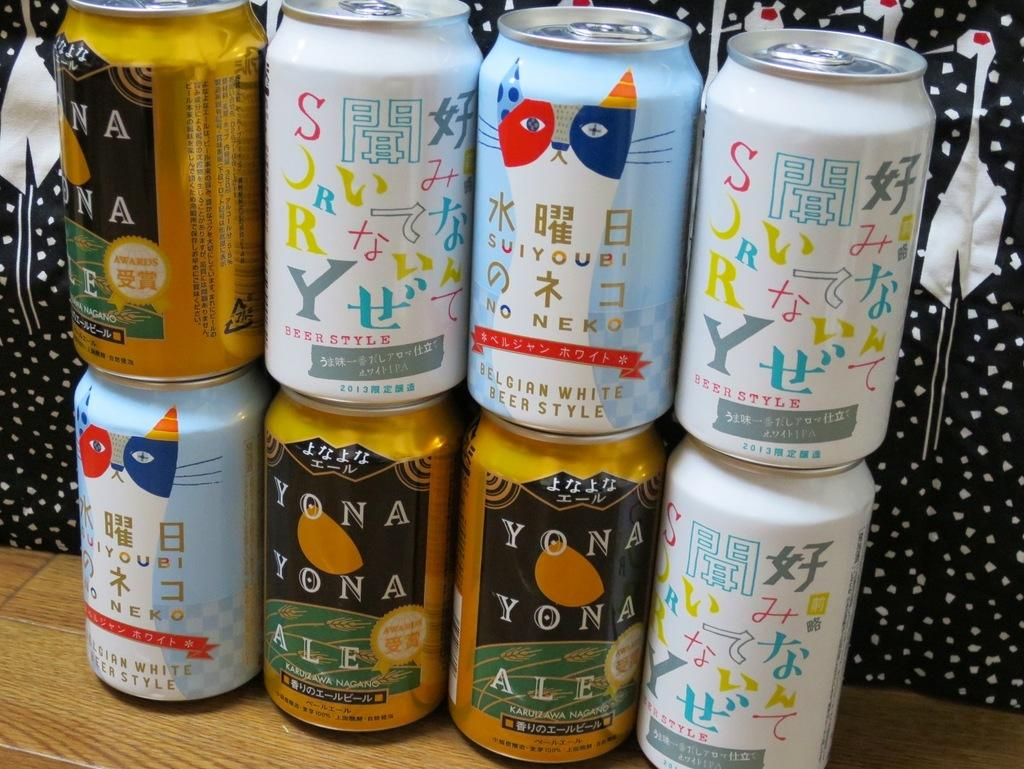<image>
Summarize the visual content of the image. a set of canned drinks including Yona Yona Ale. 